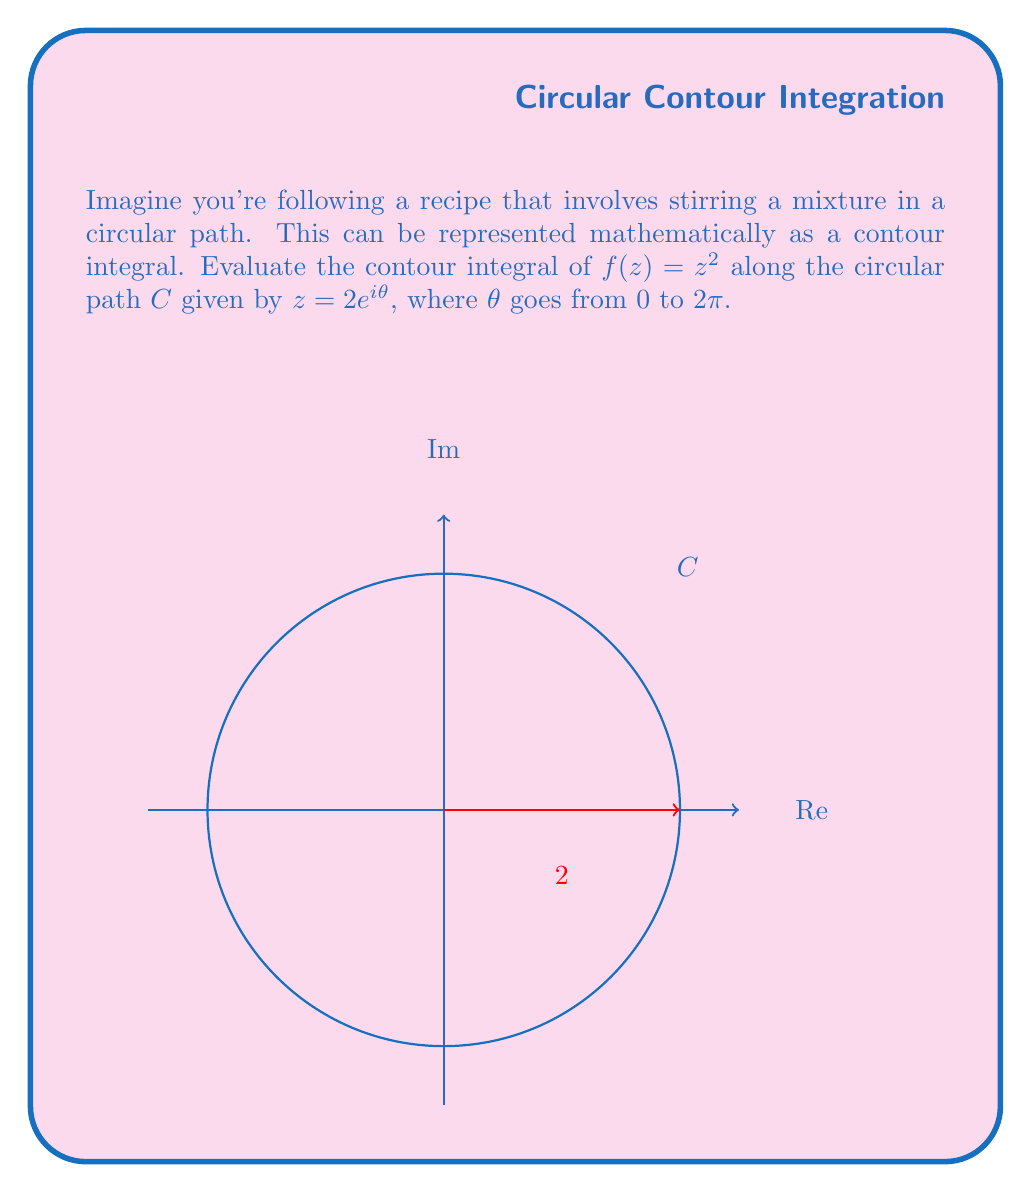Give your solution to this math problem. Let's break this down step-by-step:

1) The contour integral is given by:
   $$\oint_C f(z) dz = \oint_C z^2 dz$$

2) We're given that $z = 2e^{i\theta}$, so we need to express $dz$ in terms of $\theta$:
   $$dz = 2ie^{i\theta} d\theta$$

3) Substituting $z$ and $dz$ into the integral:
   $$\oint_C z^2 dz = \int_0^{2\pi} (2e^{i\theta})^2 \cdot 2ie^{i\theta} d\theta$$

4) Simplify the integrand:
   $$= \int_0^{2\pi} 8i e^{3i\theta} d\theta$$

5) Integrate:
   $$= 8i \left[ \frac{e^{3i\theta}}{3i} \right]_0^{2\pi}$$

6) Evaluate the limits:
   $$= 8i \left( \frac{e^{6\pi i}}{3i} - \frac{e^0}{3i} \right)$$

7) Simplify, noting that $e^{6\pi i} = 1$:
   $$= 8i \left( \frac{1}{3i} - \frac{1}{3i} \right) = 0$$

Therefore, the contour integral evaluates to 0.
Answer: $0$ 